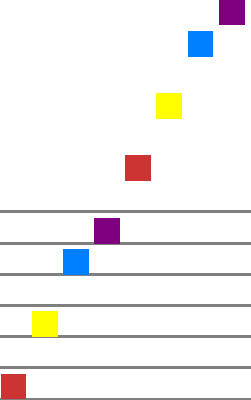As a music teacher, you're introducing your students to different musical scales. Based on the piano roll representation shown above, which type of musical scale is being depicted? Let's analyze this piano roll representation step-by-step:

1. We can see that the pattern spans exactly one octave (12 semitones).

2. There are 8 notes in total, including the repeated note at the top.

3. The interval pattern between consecutive notes is:
   - From 1st to 2nd note: 2 semitones (whole step)
   - From 2nd to 3rd note: 2 semitones (whole step)
   - From 3rd to 4th note: 1 semitone (half step)
   - From 4th to 5th note: 2 semitones (whole step)
   - From 5th to 6th note: 2 semitones (whole step)
   - From 6th to 7th note: 2 semitones (whole step)
   - From 7th to 8th note: 1 semitone (half step)

4. This interval pattern of "Whole-Whole-Half-Whole-Whole-Whole-Half" is characteristic of the major scale.

5. The major scale is one of the most fundamental scales in Western music, consisting of 7 unique notes plus the octave.

Therefore, based on the interval pattern and the number of notes, we can conclude that this piano roll representation depicts a major scale.
Answer: Major scale 